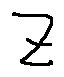Convert formula to latex. <formula><loc_0><loc_0><loc_500><loc_500>z</formula> 